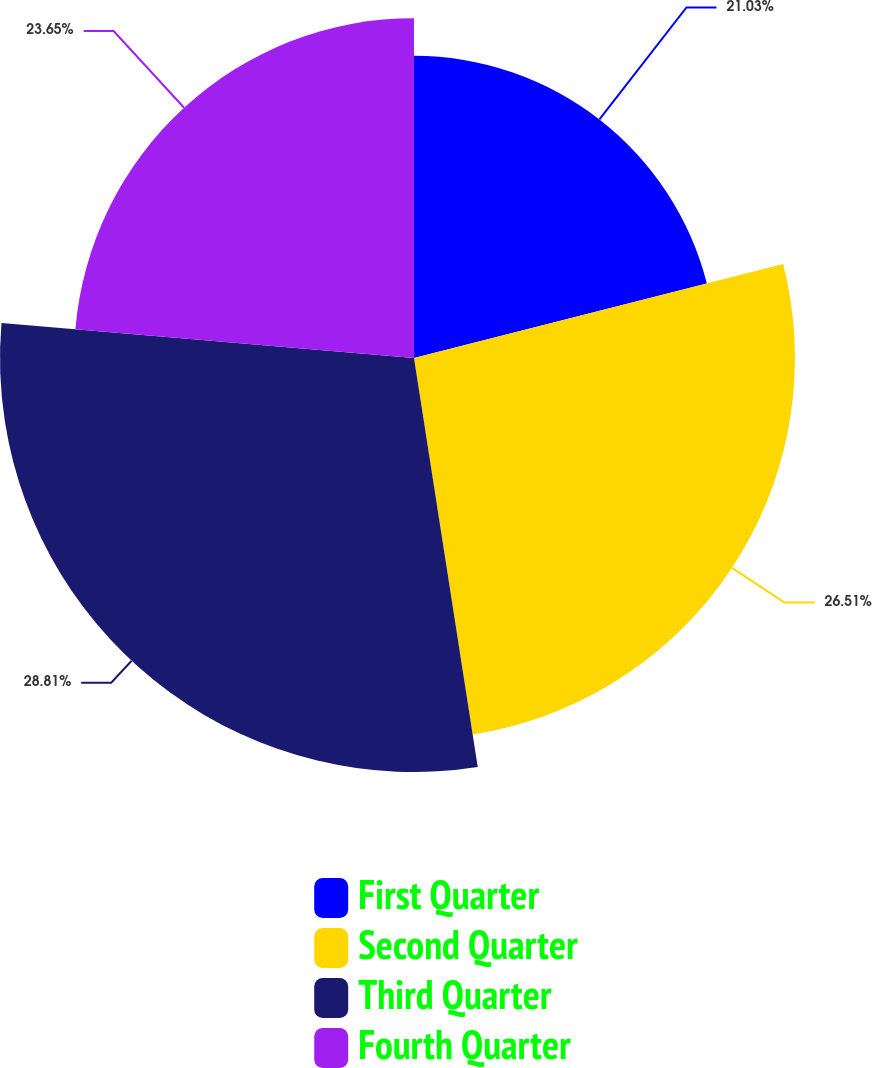Convert chart. <chart><loc_0><loc_0><loc_500><loc_500><pie_chart><fcel>First Quarter<fcel>Second Quarter<fcel>Third Quarter<fcel>Fourth Quarter<nl><fcel>21.03%<fcel>26.51%<fcel>28.81%<fcel>23.65%<nl></chart> 